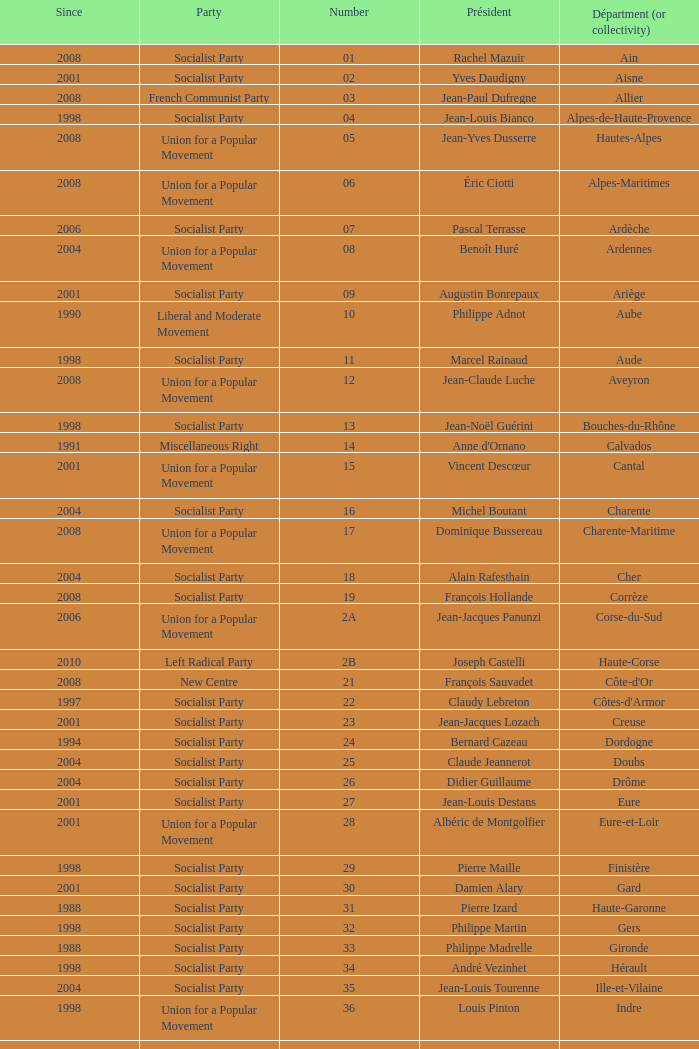Who is the president from the Union for a Popular Movement party that represents the Hautes-Alpes department? Jean-Yves Dusserre. 